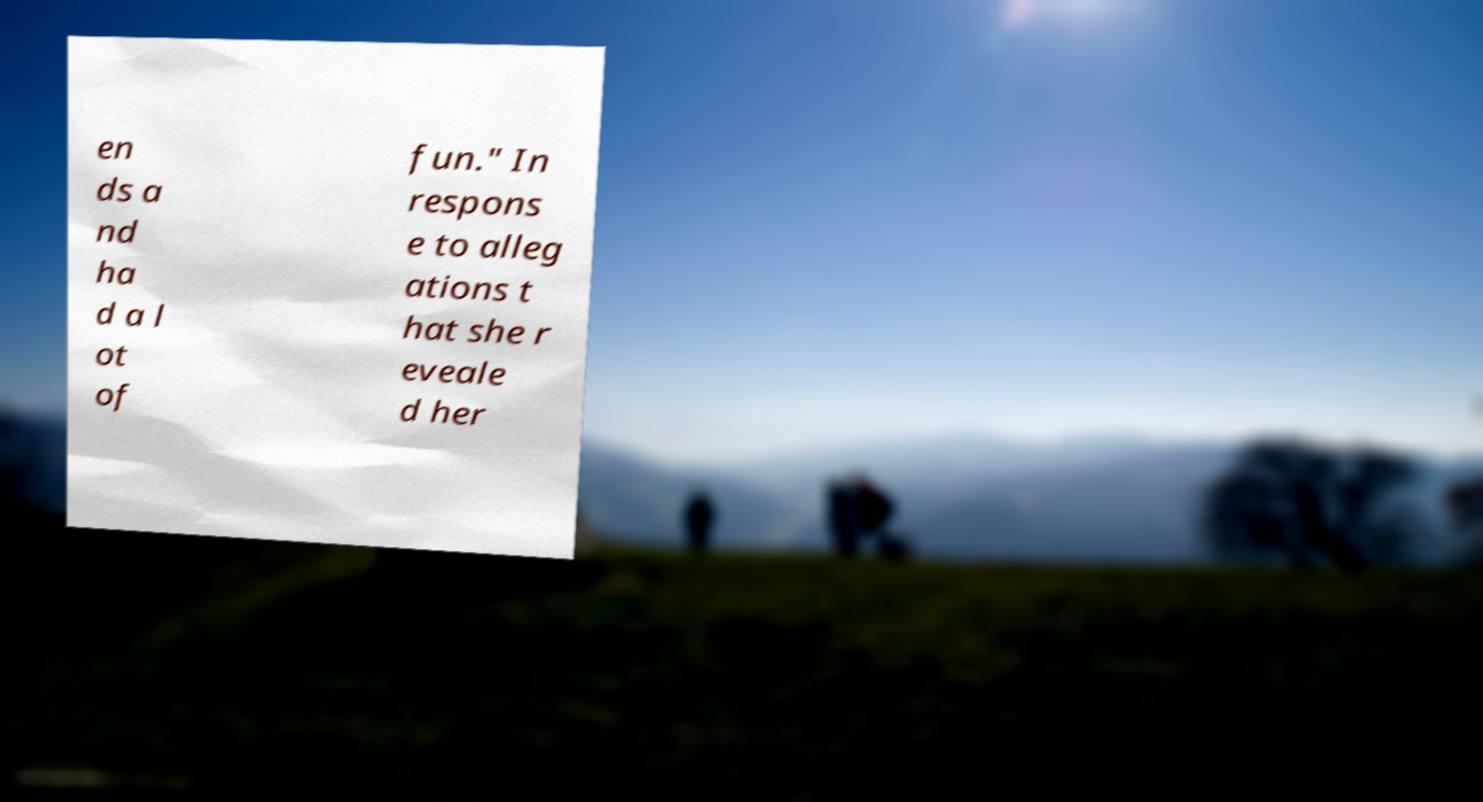Could you extract and type out the text from this image? en ds a nd ha d a l ot of fun." In respons e to alleg ations t hat she r eveale d her 